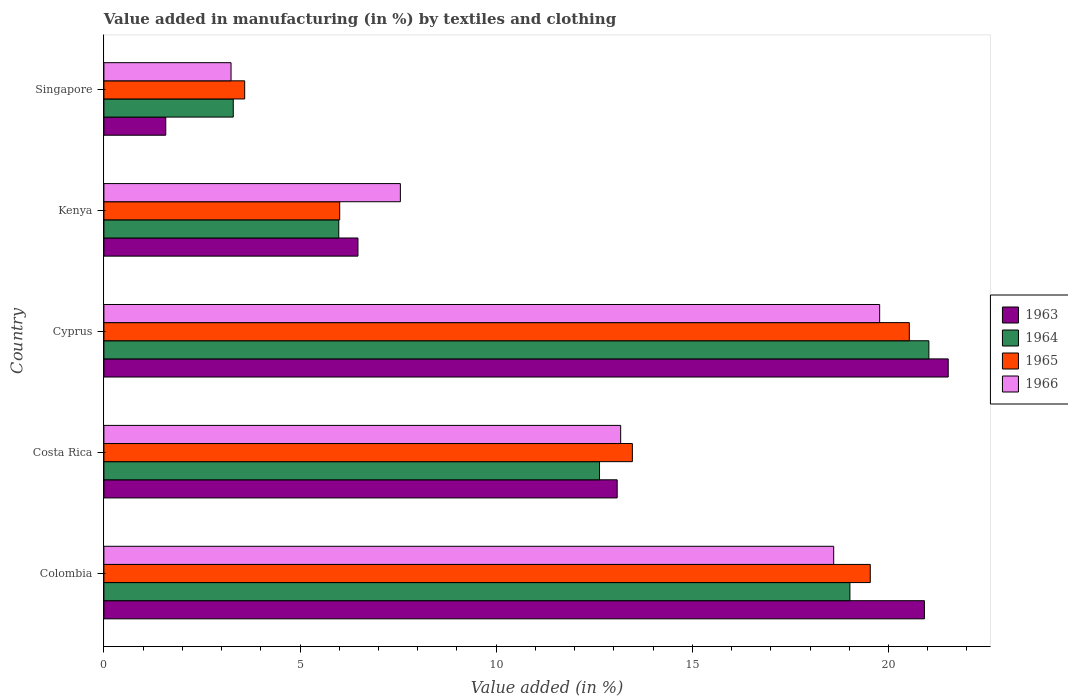How many different coloured bars are there?
Offer a terse response. 4. How many groups of bars are there?
Offer a very short reply. 5. Are the number of bars per tick equal to the number of legend labels?
Give a very brief answer. Yes. How many bars are there on the 3rd tick from the top?
Offer a terse response. 4. How many bars are there on the 2nd tick from the bottom?
Your answer should be very brief. 4. What is the label of the 2nd group of bars from the top?
Offer a terse response. Kenya. In how many cases, is the number of bars for a given country not equal to the number of legend labels?
Your answer should be compact. 0. What is the percentage of value added in manufacturing by textiles and clothing in 1964 in Cyprus?
Make the answer very short. 21.03. Across all countries, what is the maximum percentage of value added in manufacturing by textiles and clothing in 1966?
Your answer should be compact. 19.78. Across all countries, what is the minimum percentage of value added in manufacturing by textiles and clothing in 1965?
Ensure brevity in your answer.  3.59. In which country was the percentage of value added in manufacturing by textiles and clothing in 1964 maximum?
Make the answer very short. Cyprus. In which country was the percentage of value added in manufacturing by textiles and clothing in 1964 minimum?
Make the answer very short. Singapore. What is the total percentage of value added in manufacturing by textiles and clothing in 1964 in the graph?
Your response must be concise. 61.97. What is the difference between the percentage of value added in manufacturing by textiles and clothing in 1966 in Colombia and that in Kenya?
Ensure brevity in your answer.  11.05. What is the difference between the percentage of value added in manufacturing by textiles and clothing in 1964 in Colombia and the percentage of value added in manufacturing by textiles and clothing in 1965 in Costa Rica?
Give a very brief answer. 5.55. What is the average percentage of value added in manufacturing by textiles and clothing in 1963 per country?
Provide a short and direct response. 12.72. What is the difference between the percentage of value added in manufacturing by textiles and clothing in 1965 and percentage of value added in manufacturing by textiles and clothing in 1963 in Colombia?
Provide a succinct answer. -1.38. What is the ratio of the percentage of value added in manufacturing by textiles and clothing in 1966 in Cyprus to that in Kenya?
Your response must be concise. 2.62. What is the difference between the highest and the second highest percentage of value added in manufacturing by textiles and clothing in 1966?
Ensure brevity in your answer.  1.17. What is the difference between the highest and the lowest percentage of value added in manufacturing by textiles and clothing in 1963?
Give a very brief answer. 19.95. Is it the case that in every country, the sum of the percentage of value added in manufacturing by textiles and clothing in 1966 and percentage of value added in manufacturing by textiles and clothing in 1963 is greater than the sum of percentage of value added in manufacturing by textiles and clothing in 1964 and percentage of value added in manufacturing by textiles and clothing in 1965?
Make the answer very short. No. What does the 2nd bar from the top in Kenya represents?
Make the answer very short. 1965. What does the 2nd bar from the bottom in Kenya represents?
Your answer should be compact. 1964. How many countries are there in the graph?
Offer a terse response. 5. What is the difference between two consecutive major ticks on the X-axis?
Provide a succinct answer. 5. Are the values on the major ticks of X-axis written in scientific E-notation?
Offer a very short reply. No. Does the graph contain any zero values?
Offer a terse response. No. Does the graph contain grids?
Provide a succinct answer. No. What is the title of the graph?
Give a very brief answer. Value added in manufacturing (in %) by textiles and clothing. Does "1996" appear as one of the legend labels in the graph?
Offer a terse response. No. What is the label or title of the X-axis?
Your answer should be compact. Value added (in %). What is the label or title of the Y-axis?
Make the answer very short. Country. What is the Value added (in %) in 1963 in Colombia?
Ensure brevity in your answer.  20.92. What is the Value added (in %) in 1964 in Colombia?
Your response must be concise. 19.02. What is the Value added (in %) in 1965 in Colombia?
Give a very brief answer. 19.54. What is the Value added (in %) in 1966 in Colombia?
Offer a terse response. 18.6. What is the Value added (in %) in 1963 in Costa Rica?
Provide a succinct answer. 13.08. What is the Value added (in %) of 1964 in Costa Rica?
Keep it short and to the point. 12.63. What is the Value added (in %) of 1965 in Costa Rica?
Your answer should be very brief. 13.47. What is the Value added (in %) in 1966 in Costa Rica?
Give a very brief answer. 13.17. What is the Value added (in %) in 1963 in Cyprus?
Give a very brief answer. 21.52. What is the Value added (in %) in 1964 in Cyprus?
Give a very brief answer. 21.03. What is the Value added (in %) of 1965 in Cyprus?
Give a very brief answer. 20.53. What is the Value added (in %) in 1966 in Cyprus?
Provide a succinct answer. 19.78. What is the Value added (in %) in 1963 in Kenya?
Your answer should be compact. 6.48. What is the Value added (in %) of 1964 in Kenya?
Give a very brief answer. 5.99. What is the Value added (in %) of 1965 in Kenya?
Your response must be concise. 6.01. What is the Value added (in %) in 1966 in Kenya?
Provide a short and direct response. 7.56. What is the Value added (in %) in 1963 in Singapore?
Your answer should be compact. 1.58. What is the Value added (in %) of 1964 in Singapore?
Ensure brevity in your answer.  3.3. What is the Value added (in %) of 1965 in Singapore?
Your answer should be very brief. 3.59. What is the Value added (in %) of 1966 in Singapore?
Your answer should be very brief. 3.24. Across all countries, what is the maximum Value added (in %) of 1963?
Your response must be concise. 21.52. Across all countries, what is the maximum Value added (in %) of 1964?
Make the answer very short. 21.03. Across all countries, what is the maximum Value added (in %) of 1965?
Offer a very short reply. 20.53. Across all countries, what is the maximum Value added (in %) of 1966?
Your answer should be very brief. 19.78. Across all countries, what is the minimum Value added (in %) of 1963?
Ensure brevity in your answer.  1.58. Across all countries, what is the minimum Value added (in %) in 1964?
Ensure brevity in your answer.  3.3. Across all countries, what is the minimum Value added (in %) of 1965?
Offer a very short reply. 3.59. Across all countries, what is the minimum Value added (in %) of 1966?
Keep it short and to the point. 3.24. What is the total Value added (in %) in 1963 in the graph?
Offer a terse response. 63.58. What is the total Value added (in %) in 1964 in the graph?
Make the answer very short. 61.97. What is the total Value added (in %) in 1965 in the graph?
Offer a terse response. 63.14. What is the total Value added (in %) of 1966 in the graph?
Give a very brief answer. 62.35. What is the difference between the Value added (in %) in 1963 in Colombia and that in Costa Rica?
Ensure brevity in your answer.  7.83. What is the difference between the Value added (in %) of 1964 in Colombia and that in Costa Rica?
Offer a terse response. 6.38. What is the difference between the Value added (in %) of 1965 in Colombia and that in Costa Rica?
Keep it short and to the point. 6.06. What is the difference between the Value added (in %) in 1966 in Colombia and that in Costa Rica?
Your answer should be very brief. 5.43. What is the difference between the Value added (in %) in 1963 in Colombia and that in Cyprus?
Give a very brief answer. -0.61. What is the difference between the Value added (in %) of 1964 in Colombia and that in Cyprus?
Make the answer very short. -2.01. What is the difference between the Value added (in %) in 1965 in Colombia and that in Cyprus?
Your answer should be very brief. -0.99. What is the difference between the Value added (in %) in 1966 in Colombia and that in Cyprus?
Offer a very short reply. -1.17. What is the difference between the Value added (in %) in 1963 in Colombia and that in Kenya?
Your answer should be compact. 14.44. What is the difference between the Value added (in %) of 1964 in Colombia and that in Kenya?
Give a very brief answer. 13.03. What is the difference between the Value added (in %) in 1965 in Colombia and that in Kenya?
Offer a terse response. 13.53. What is the difference between the Value added (in %) in 1966 in Colombia and that in Kenya?
Your response must be concise. 11.05. What is the difference between the Value added (in %) of 1963 in Colombia and that in Singapore?
Keep it short and to the point. 19.34. What is the difference between the Value added (in %) of 1964 in Colombia and that in Singapore?
Keep it short and to the point. 15.72. What is the difference between the Value added (in %) in 1965 in Colombia and that in Singapore?
Provide a short and direct response. 15.95. What is the difference between the Value added (in %) of 1966 in Colombia and that in Singapore?
Your answer should be very brief. 15.36. What is the difference between the Value added (in %) of 1963 in Costa Rica and that in Cyprus?
Your response must be concise. -8.44. What is the difference between the Value added (in %) in 1964 in Costa Rica and that in Cyprus?
Give a very brief answer. -8.4. What is the difference between the Value added (in %) in 1965 in Costa Rica and that in Cyprus?
Your response must be concise. -7.06. What is the difference between the Value added (in %) of 1966 in Costa Rica and that in Cyprus?
Provide a succinct answer. -6.6. What is the difference between the Value added (in %) of 1963 in Costa Rica and that in Kenya?
Make the answer very short. 6.61. What is the difference between the Value added (in %) in 1964 in Costa Rica and that in Kenya?
Offer a very short reply. 6.65. What is the difference between the Value added (in %) of 1965 in Costa Rica and that in Kenya?
Offer a very short reply. 7.46. What is the difference between the Value added (in %) of 1966 in Costa Rica and that in Kenya?
Ensure brevity in your answer.  5.62. What is the difference between the Value added (in %) in 1963 in Costa Rica and that in Singapore?
Offer a terse response. 11.51. What is the difference between the Value added (in %) of 1964 in Costa Rica and that in Singapore?
Ensure brevity in your answer.  9.34. What is the difference between the Value added (in %) of 1965 in Costa Rica and that in Singapore?
Make the answer very short. 9.88. What is the difference between the Value added (in %) in 1966 in Costa Rica and that in Singapore?
Make the answer very short. 9.93. What is the difference between the Value added (in %) of 1963 in Cyprus and that in Kenya?
Ensure brevity in your answer.  15.05. What is the difference between the Value added (in %) in 1964 in Cyprus and that in Kenya?
Your response must be concise. 15.04. What is the difference between the Value added (in %) of 1965 in Cyprus and that in Kenya?
Give a very brief answer. 14.52. What is the difference between the Value added (in %) of 1966 in Cyprus and that in Kenya?
Your answer should be very brief. 12.22. What is the difference between the Value added (in %) in 1963 in Cyprus and that in Singapore?
Make the answer very short. 19.95. What is the difference between the Value added (in %) of 1964 in Cyprus and that in Singapore?
Offer a very short reply. 17.73. What is the difference between the Value added (in %) in 1965 in Cyprus and that in Singapore?
Your answer should be compact. 16.94. What is the difference between the Value added (in %) of 1966 in Cyprus and that in Singapore?
Ensure brevity in your answer.  16.53. What is the difference between the Value added (in %) in 1963 in Kenya and that in Singapore?
Ensure brevity in your answer.  4.9. What is the difference between the Value added (in %) in 1964 in Kenya and that in Singapore?
Give a very brief answer. 2.69. What is the difference between the Value added (in %) in 1965 in Kenya and that in Singapore?
Offer a terse response. 2.42. What is the difference between the Value added (in %) in 1966 in Kenya and that in Singapore?
Provide a short and direct response. 4.32. What is the difference between the Value added (in %) of 1963 in Colombia and the Value added (in %) of 1964 in Costa Rica?
Make the answer very short. 8.28. What is the difference between the Value added (in %) in 1963 in Colombia and the Value added (in %) in 1965 in Costa Rica?
Provide a short and direct response. 7.44. What is the difference between the Value added (in %) of 1963 in Colombia and the Value added (in %) of 1966 in Costa Rica?
Provide a succinct answer. 7.74. What is the difference between the Value added (in %) in 1964 in Colombia and the Value added (in %) in 1965 in Costa Rica?
Ensure brevity in your answer.  5.55. What is the difference between the Value added (in %) in 1964 in Colombia and the Value added (in %) in 1966 in Costa Rica?
Provide a succinct answer. 5.84. What is the difference between the Value added (in %) in 1965 in Colombia and the Value added (in %) in 1966 in Costa Rica?
Your response must be concise. 6.36. What is the difference between the Value added (in %) in 1963 in Colombia and the Value added (in %) in 1964 in Cyprus?
Provide a short and direct response. -0.11. What is the difference between the Value added (in %) of 1963 in Colombia and the Value added (in %) of 1965 in Cyprus?
Make the answer very short. 0.39. What is the difference between the Value added (in %) of 1963 in Colombia and the Value added (in %) of 1966 in Cyprus?
Your answer should be very brief. 1.14. What is the difference between the Value added (in %) in 1964 in Colombia and the Value added (in %) in 1965 in Cyprus?
Offer a very short reply. -1.51. What is the difference between the Value added (in %) in 1964 in Colombia and the Value added (in %) in 1966 in Cyprus?
Provide a short and direct response. -0.76. What is the difference between the Value added (in %) of 1965 in Colombia and the Value added (in %) of 1966 in Cyprus?
Ensure brevity in your answer.  -0.24. What is the difference between the Value added (in %) in 1963 in Colombia and the Value added (in %) in 1964 in Kenya?
Offer a very short reply. 14.93. What is the difference between the Value added (in %) of 1963 in Colombia and the Value added (in %) of 1965 in Kenya?
Make the answer very short. 14.91. What is the difference between the Value added (in %) of 1963 in Colombia and the Value added (in %) of 1966 in Kenya?
Your answer should be very brief. 13.36. What is the difference between the Value added (in %) of 1964 in Colombia and the Value added (in %) of 1965 in Kenya?
Your answer should be very brief. 13.01. What is the difference between the Value added (in %) of 1964 in Colombia and the Value added (in %) of 1966 in Kenya?
Offer a very short reply. 11.46. What is the difference between the Value added (in %) of 1965 in Colombia and the Value added (in %) of 1966 in Kenya?
Your response must be concise. 11.98. What is the difference between the Value added (in %) in 1963 in Colombia and the Value added (in %) in 1964 in Singapore?
Your response must be concise. 17.62. What is the difference between the Value added (in %) of 1963 in Colombia and the Value added (in %) of 1965 in Singapore?
Provide a succinct answer. 17.33. What is the difference between the Value added (in %) of 1963 in Colombia and the Value added (in %) of 1966 in Singapore?
Your answer should be very brief. 17.68. What is the difference between the Value added (in %) in 1964 in Colombia and the Value added (in %) in 1965 in Singapore?
Make the answer very short. 15.43. What is the difference between the Value added (in %) of 1964 in Colombia and the Value added (in %) of 1966 in Singapore?
Provide a short and direct response. 15.78. What is the difference between the Value added (in %) of 1965 in Colombia and the Value added (in %) of 1966 in Singapore?
Your response must be concise. 16.3. What is the difference between the Value added (in %) in 1963 in Costa Rica and the Value added (in %) in 1964 in Cyprus?
Your response must be concise. -7.95. What is the difference between the Value added (in %) in 1963 in Costa Rica and the Value added (in %) in 1965 in Cyprus?
Keep it short and to the point. -7.45. What is the difference between the Value added (in %) in 1963 in Costa Rica and the Value added (in %) in 1966 in Cyprus?
Your response must be concise. -6.69. What is the difference between the Value added (in %) of 1964 in Costa Rica and the Value added (in %) of 1965 in Cyprus?
Your response must be concise. -7.9. What is the difference between the Value added (in %) of 1964 in Costa Rica and the Value added (in %) of 1966 in Cyprus?
Give a very brief answer. -7.14. What is the difference between the Value added (in %) in 1965 in Costa Rica and the Value added (in %) in 1966 in Cyprus?
Provide a short and direct response. -6.3. What is the difference between the Value added (in %) in 1963 in Costa Rica and the Value added (in %) in 1964 in Kenya?
Your answer should be compact. 7.1. What is the difference between the Value added (in %) of 1963 in Costa Rica and the Value added (in %) of 1965 in Kenya?
Make the answer very short. 7.07. What is the difference between the Value added (in %) of 1963 in Costa Rica and the Value added (in %) of 1966 in Kenya?
Give a very brief answer. 5.53. What is the difference between the Value added (in %) of 1964 in Costa Rica and the Value added (in %) of 1965 in Kenya?
Keep it short and to the point. 6.62. What is the difference between the Value added (in %) of 1964 in Costa Rica and the Value added (in %) of 1966 in Kenya?
Your answer should be very brief. 5.08. What is the difference between the Value added (in %) of 1965 in Costa Rica and the Value added (in %) of 1966 in Kenya?
Offer a terse response. 5.91. What is the difference between the Value added (in %) in 1963 in Costa Rica and the Value added (in %) in 1964 in Singapore?
Your answer should be compact. 9.79. What is the difference between the Value added (in %) of 1963 in Costa Rica and the Value added (in %) of 1965 in Singapore?
Make the answer very short. 9.5. What is the difference between the Value added (in %) in 1963 in Costa Rica and the Value added (in %) in 1966 in Singapore?
Provide a succinct answer. 9.84. What is the difference between the Value added (in %) of 1964 in Costa Rica and the Value added (in %) of 1965 in Singapore?
Provide a short and direct response. 9.04. What is the difference between the Value added (in %) of 1964 in Costa Rica and the Value added (in %) of 1966 in Singapore?
Ensure brevity in your answer.  9.39. What is the difference between the Value added (in %) of 1965 in Costa Rica and the Value added (in %) of 1966 in Singapore?
Offer a terse response. 10.23. What is the difference between the Value added (in %) of 1963 in Cyprus and the Value added (in %) of 1964 in Kenya?
Offer a terse response. 15.54. What is the difference between the Value added (in %) in 1963 in Cyprus and the Value added (in %) in 1965 in Kenya?
Give a very brief answer. 15.51. What is the difference between the Value added (in %) in 1963 in Cyprus and the Value added (in %) in 1966 in Kenya?
Ensure brevity in your answer.  13.97. What is the difference between the Value added (in %) in 1964 in Cyprus and the Value added (in %) in 1965 in Kenya?
Keep it short and to the point. 15.02. What is the difference between the Value added (in %) in 1964 in Cyprus and the Value added (in %) in 1966 in Kenya?
Make the answer very short. 13.47. What is the difference between the Value added (in %) in 1965 in Cyprus and the Value added (in %) in 1966 in Kenya?
Offer a very short reply. 12.97. What is the difference between the Value added (in %) in 1963 in Cyprus and the Value added (in %) in 1964 in Singapore?
Provide a succinct answer. 18.23. What is the difference between the Value added (in %) in 1963 in Cyprus and the Value added (in %) in 1965 in Singapore?
Your response must be concise. 17.93. What is the difference between the Value added (in %) of 1963 in Cyprus and the Value added (in %) of 1966 in Singapore?
Your answer should be compact. 18.28. What is the difference between the Value added (in %) in 1964 in Cyprus and the Value added (in %) in 1965 in Singapore?
Keep it short and to the point. 17.44. What is the difference between the Value added (in %) in 1964 in Cyprus and the Value added (in %) in 1966 in Singapore?
Give a very brief answer. 17.79. What is the difference between the Value added (in %) in 1965 in Cyprus and the Value added (in %) in 1966 in Singapore?
Provide a short and direct response. 17.29. What is the difference between the Value added (in %) in 1963 in Kenya and the Value added (in %) in 1964 in Singapore?
Provide a succinct answer. 3.18. What is the difference between the Value added (in %) in 1963 in Kenya and the Value added (in %) in 1965 in Singapore?
Ensure brevity in your answer.  2.89. What is the difference between the Value added (in %) of 1963 in Kenya and the Value added (in %) of 1966 in Singapore?
Offer a very short reply. 3.24. What is the difference between the Value added (in %) of 1964 in Kenya and the Value added (in %) of 1965 in Singapore?
Your answer should be compact. 2.4. What is the difference between the Value added (in %) of 1964 in Kenya and the Value added (in %) of 1966 in Singapore?
Provide a succinct answer. 2.75. What is the difference between the Value added (in %) of 1965 in Kenya and the Value added (in %) of 1966 in Singapore?
Offer a very short reply. 2.77. What is the average Value added (in %) of 1963 per country?
Your response must be concise. 12.72. What is the average Value added (in %) in 1964 per country?
Provide a short and direct response. 12.39. What is the average Value added (in %) in 1965 per country?
Keep it short and to the point. 12.63. What is the average Value added (in %) of 1966 per country?
Keep it short and to the point. 12.47. What is the difference between the Value added (in %) of 1963 and Value added (in %) of 1964 in Colombia?
Keep it short and to the point. 1.9. What is the difference between the Value added (in %) of 1963 and Value added (in %) of 1965 in Colombia?
Your response must be concise. 1.38. What is the difference between the Value added (in %) of 1963 and Value added (in %) of 1966 in Colombia?
Give a very brief answer. 2.31. What is the difference between the Value added (in %) in 1964 and Value added (in %) in 1965 in Colombia?
Your response must be concise. -0.52. What is the difference between the Value added (in %) of 1964 and Value added (in %) of 1966 in Colombia?
Your answer should be compact. 0.41. What is the difference between the Value added (in %) of 1965 and Value added (in %) of 1966 in Colombia?
Ensure brevity in your answer.  0.93. What is the difference between the Value added (in %) in 1963 and Value added (in %) in 1964 in Costa Rica?
Make the answer very short. 0.45. What is the difference between the Value added (in %) in 1963 and Value added (in %) in 1965 in Costa Rica?
Give a very brief answer. -0.39. What is the difference between the Value added (in %) of 1963 and Value added (in %) of 1966 in Costa Rica?
Make the answer very short. -0.09. What is the difference between the Value added (in %) of 1964 and Value added (in %) of 1965 in Costa Rica?
Ensure brevity in your answer.  -0.84. What is the difference between the Value added (in %) in 1964 and Value added (in %) in 1966 in Costa Rica?
Provide a short and direct response. -0.54. What is the difference between the Value added (in %) in 1965 and Value added (in %) in 1966 in Costa Rica?
Provide a succinct answer. 0.3. What is the difference between the Value added (in %) in 1963 and Value added (in %) in 1964 in Cyprus?
Provide a short and direct response. 0.49. What is the difference between the Value added (in %) of 1963 and Value added (in %) of 1965 in Cyprus?
Offer a terse response. 0.99. What is the difference between the Value added (in %) of 1963 and Value added (in %) of 1966 in Cyprus?
Keep it short and to the point. 1.75. What is the difference between the Value added (in %) of 1964 and Value added (in %) of 1965 in Cyprus?
Your response must be concise. 0.5. What is the difference between the Value added (in %) in 1964 and Value added (in %) in 1966 in Cyprus?
Your answer should be compact. 1.25. What is the difference between the Value added (in %) in 1965 and Value added (in %) in 1966 in Cyprus?
Offer a very short reply. 0.76. What is the difference between the Value added (in %) in 1963 and Value added (in %) in 1964 in Kenya?
Offer a very short reply. 0.49. What is the difference between the Value added (in %) of 1963 and Value added (in %) of 1965 in Kenya?
Your answer should be very brief. 0.47. What is the difference between the Value added (in %) in 1963 and Value added (in %) in 1966 in Kenya?
Ensure brevity in your answer.  -1.08. What is the difference between the Value added (in %) in 1964 and Value added (in %) in 1965 in Kenya?
Provide a succinct answer. -0.02. What is the difference between the Value added (in %) of 1964 and Value added (in %) of 1966 in Kenya?
Provide a short and direct response. -1.57. What is the difference between the Value added (in %) in 1965 and Value added (in %) in 1966 in Kenya?
Make the answer very short. -1.55. What is the difference between the Value added (in %) in 1963 and Value added (in %) in 1964 in Singapore?
Keep it short and to the point. -1.72. What is the difference between the Value added (in %) in 1963 and Value added (in %) in 1965 in Singapore?
Keep it short and to the point. -2.01. What is the difference between the Value added (in %) of 1963 and Value added (in %) of 1966 in Singapore?
Keep it short and to the point. -1.66. What is the difference between the Value added (in %) in 1964 and Value added (in %) in 1965 in Singapore?
Ensure brevity in your answer.  -0.29. What is the difference between the Value added (in %) in 1964 and Value added (in %) in 1966 in Singapore?
Give a very brief answer. 0.06. What is the difference between the Value added (in %) of 1965 and Value added (in %) of 1966 in Singapore?
Ensure brevity in your answer.  0.35. What is the ratio of the Value added (in %) in 1963 in Colombia to that in Costa Rica?
Keep it short and to the point. 1.6. What is the ratio of the Value added (in %) of 1964 in Colombia to that in Costa Rica?
Make the answer very short. 1.51. What is the ratio of the Value added (in %) of 1965 in Colombia to that in Costa Rica?
Your response must be concise. 1.45. What is the ratio of the Value added (in %) of 1966 in Colombia to that in Costa Rica?
Ensure brevity in your answer.  1.41. What is the ratio of the Value added (in %) in 1963 in Colombia to that in Cyprus?
Keep it short and to the point. 0.97. What is the ratio of the Value added (in %) in 1964 in Colombia to that in Cyprus?
Make the answer very short. 0.9. What is the ratio of the Value added (in %) in 1965 in Colombia to that in Cyprus?
Provide a short and direct response. 0.95. What is the ratio of the Value added (in %) of 1966 in Colombia to that in Cyprus?
Provide a succinct answer. 0.94. What is the ratio of the Value added (in %) in 1963 in Colombia to that in Kenya?
Provide a short and direct response. 3.23. What is the ratio of the Value added (in %) in 1964 in Colombia to that in Kenya?
Make the answer very short. 3.18. What is the ratio of the Value added (in %) of 1966 in Colombia to that in Kenya?
Keep it short and to the point. 2.46. What is the ratio of the Value added (in %) of 1963 in Colombia to that in Singapore?
Your response must be concise. 13.26. What is the ratio of the Value added (in %) in 1964 in Colombia to that in Singapore?
Offer a very short reply. 5.77. What is the ratio of the Value added (in %) in 1965 in Colombia to that in Singapore?
Your answer should be very brief. 5.44. What is the ratio of the Value added (in %) in 1966 in Colombia to that in Singapore?
Your answer should be very brief. 5.74. What is the ratio of the Value added (in %) of 1963 in Costa Rica to that in Cyprus?
Your response must be concise. 0.61. What is the ratio of the Value added (in %) in 1964 in Costa Rica to that in Cyprus?
Make the answer very short. 0.6. What is the ratio of the Value added (in %) in 1965 in Costa Rica to that in Cyprus?
Give a very brief answer. 0.66. What is the ratio of the Value added (in %) in 1966 in Costa Rica to that in Cyprus?
Ensure brevity in your answer.  0.67. What is the ratio of the Value added (in %) of 1963 in Costa Rica to that in Kenya?
Your answer should be very brief. 2.02. What is the ratio of the Value added (in %) of 1964 in Costa Rica to that in Kenya?
Provide a short and direct response. 2.11. What is the ratio of the Value added (in %) in 1965 in Costa Rica to that in Kenya?
Keep it short and to the point. 2.24. What is the ratio of the Value added (in %) in 1966 in Costa Rica to that in Kenya?
Offer a terse response. 1.74. What is the ratio of the Value added (in %) of 1963 in Costa Rica to that in Singapore?
Your answer should be compact. 8.3. What is the ratio of the Value added (in %) of 1964 in Costa Rica to that in Singapore?
Your answer should be compact. 3.83. What is the ratio of the Value added (in %) in 1965 in Costa Rica to that in Singapore?
Provide a succinct answer. 3.75. What is the ratio of the Value added (in %) in 1966 in Costa Rica to that in Singapore?
Keep it short and to the point. 4.06. What is the ratio of the Value added (in %) in 1963 in Cyprus to that in Kenya?
Keep it short and to the point. 3.32. What is the ratio of the Value added (in %) in 1964 in Cyprus to that in Kenya?
Make the answer very short. 3.51. What is the ratio of the Value added (in %) of 1965 in Cyprus to that in Kenya?
Your answer should be very brief. 3.42. What is the ratio of the Value added (in %) in 1966 in Cyprus to that in Kenya?
Offer a terse response. 2.62. What is the ratio of the Value added (in %) in 1963 in Cyprus to that in Singapore?
Offer a very short reply. 13.65. What is the ratio of the Value added (in %) in 1964 in Cyprus to that in Singapore?
Ensure brevity in your answer.  6.38. What is the ratio of the Value added (in %) in 1965 in Cyprus to that in Singapore?
Offer a terse response. 5.72. What is the ratio of the Value added (in %) in 1966 in Cyprus to that in Singapore?
Your answer should be very brief. 6.1. What is the ratio of the Value added (in %) of 1963 in Kenya to that in Singapore?
Keep it short and to the point. 4.11. What is the ratio of the Value added (in %) in 1964 in Kenya to that in Singapore?
Offer a very short reply. 1.82. What is the ratio of the Value added (in %) in 1965 in Kenya to that in Singapore?
Offer a terse response. 1.67. What is the ratio of the Value added (in %) of 1966 in Kenya to that in Singapore?
Keep it short and to the point. 2.33. What is the difference between the highest and the second highest Value added (in %) of 1963?
Offer a very short reply. 0.61. What is the difference between the highest and the second highest Value added (in %) in 1964?
Provide a short and direct response. 2.01. What is the difference between the highest and the second highest Value added (in %) in 1966?
Your answer should be compact. 1.17. What is the difference between the highest and the lowest Value added (in %) in 1963?
Offer a very short reply. 19.95. What is the difference between the highest and the lowest Value added (in %) of 1964?
Make the answer very short. 17.73. What is the difference between the highest and the lowest Value added (in %) in 1965?
Your response must be concise. 16.94. What is the difference between the highest and the lowest Value added (in %) in 1966?
Your response must be concise. 16.53. 